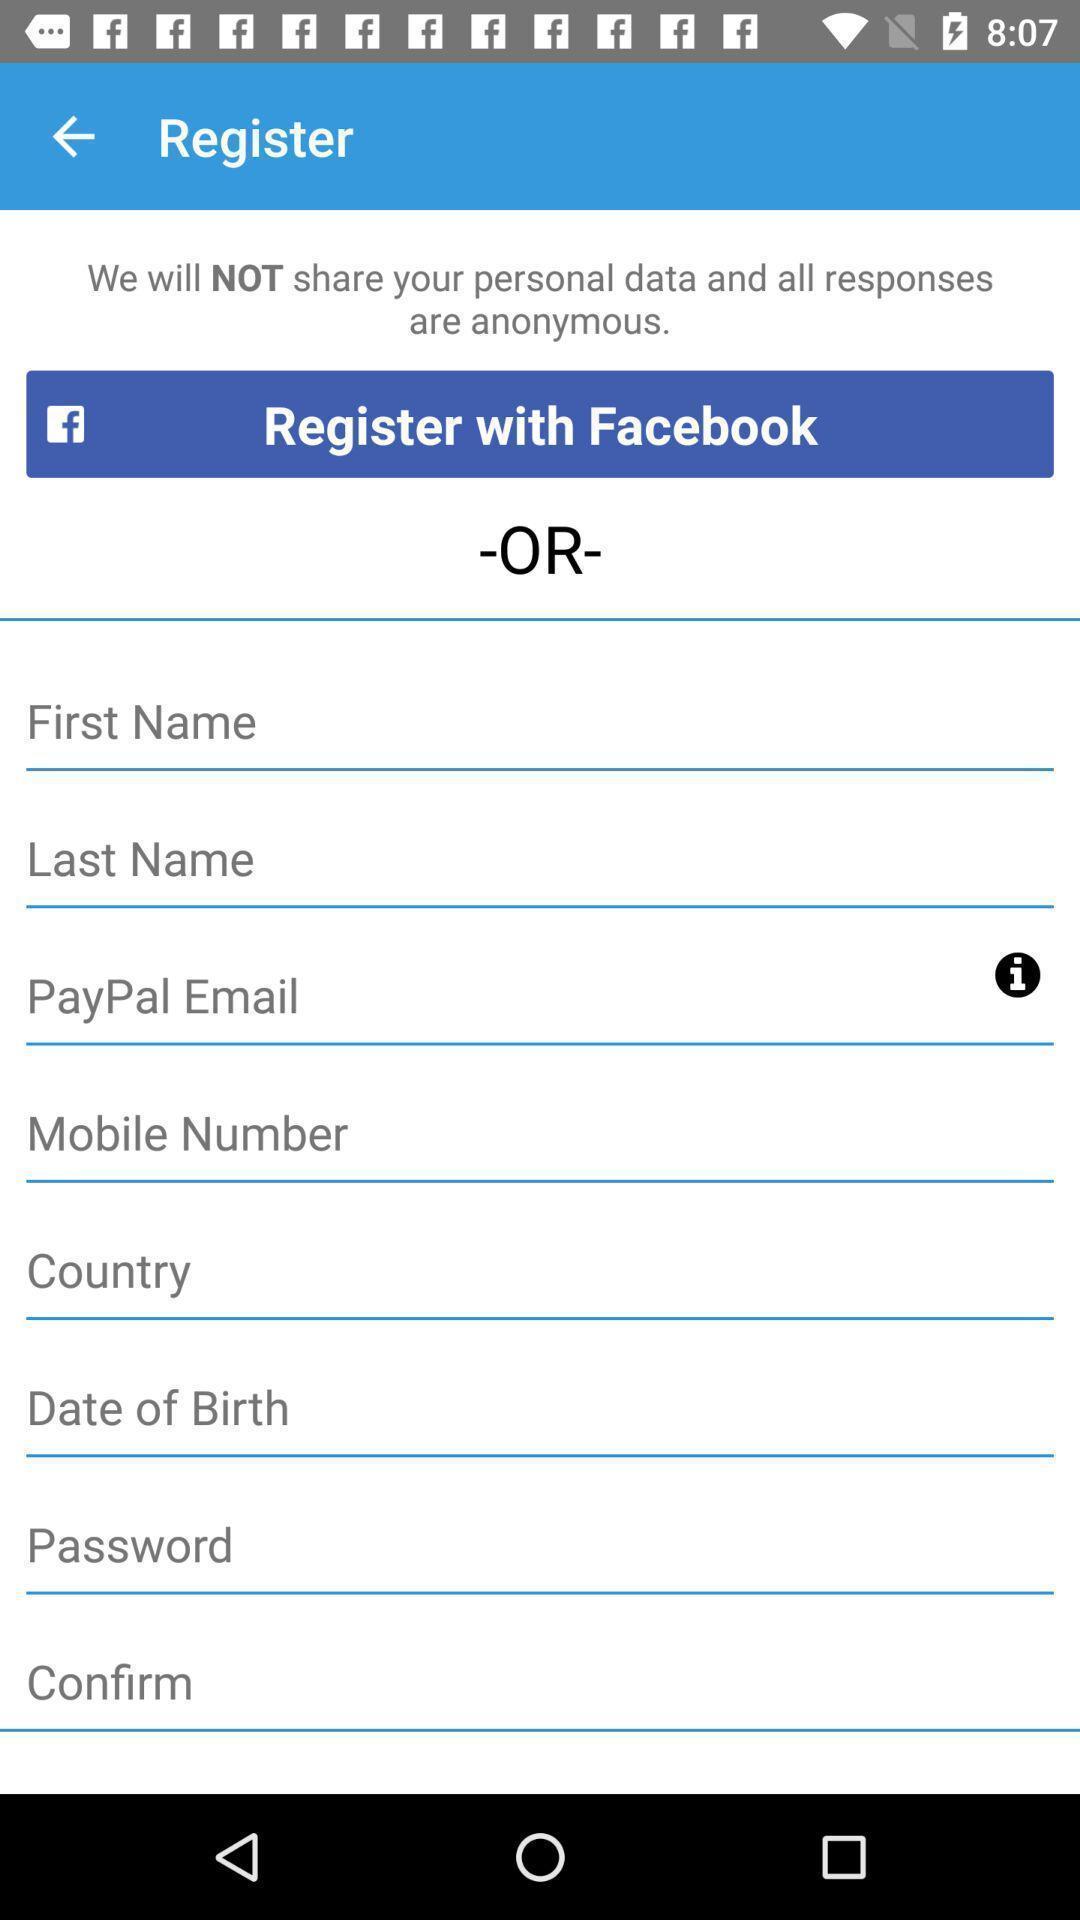What can you discern from this picture? Screen showing register option for an app. 